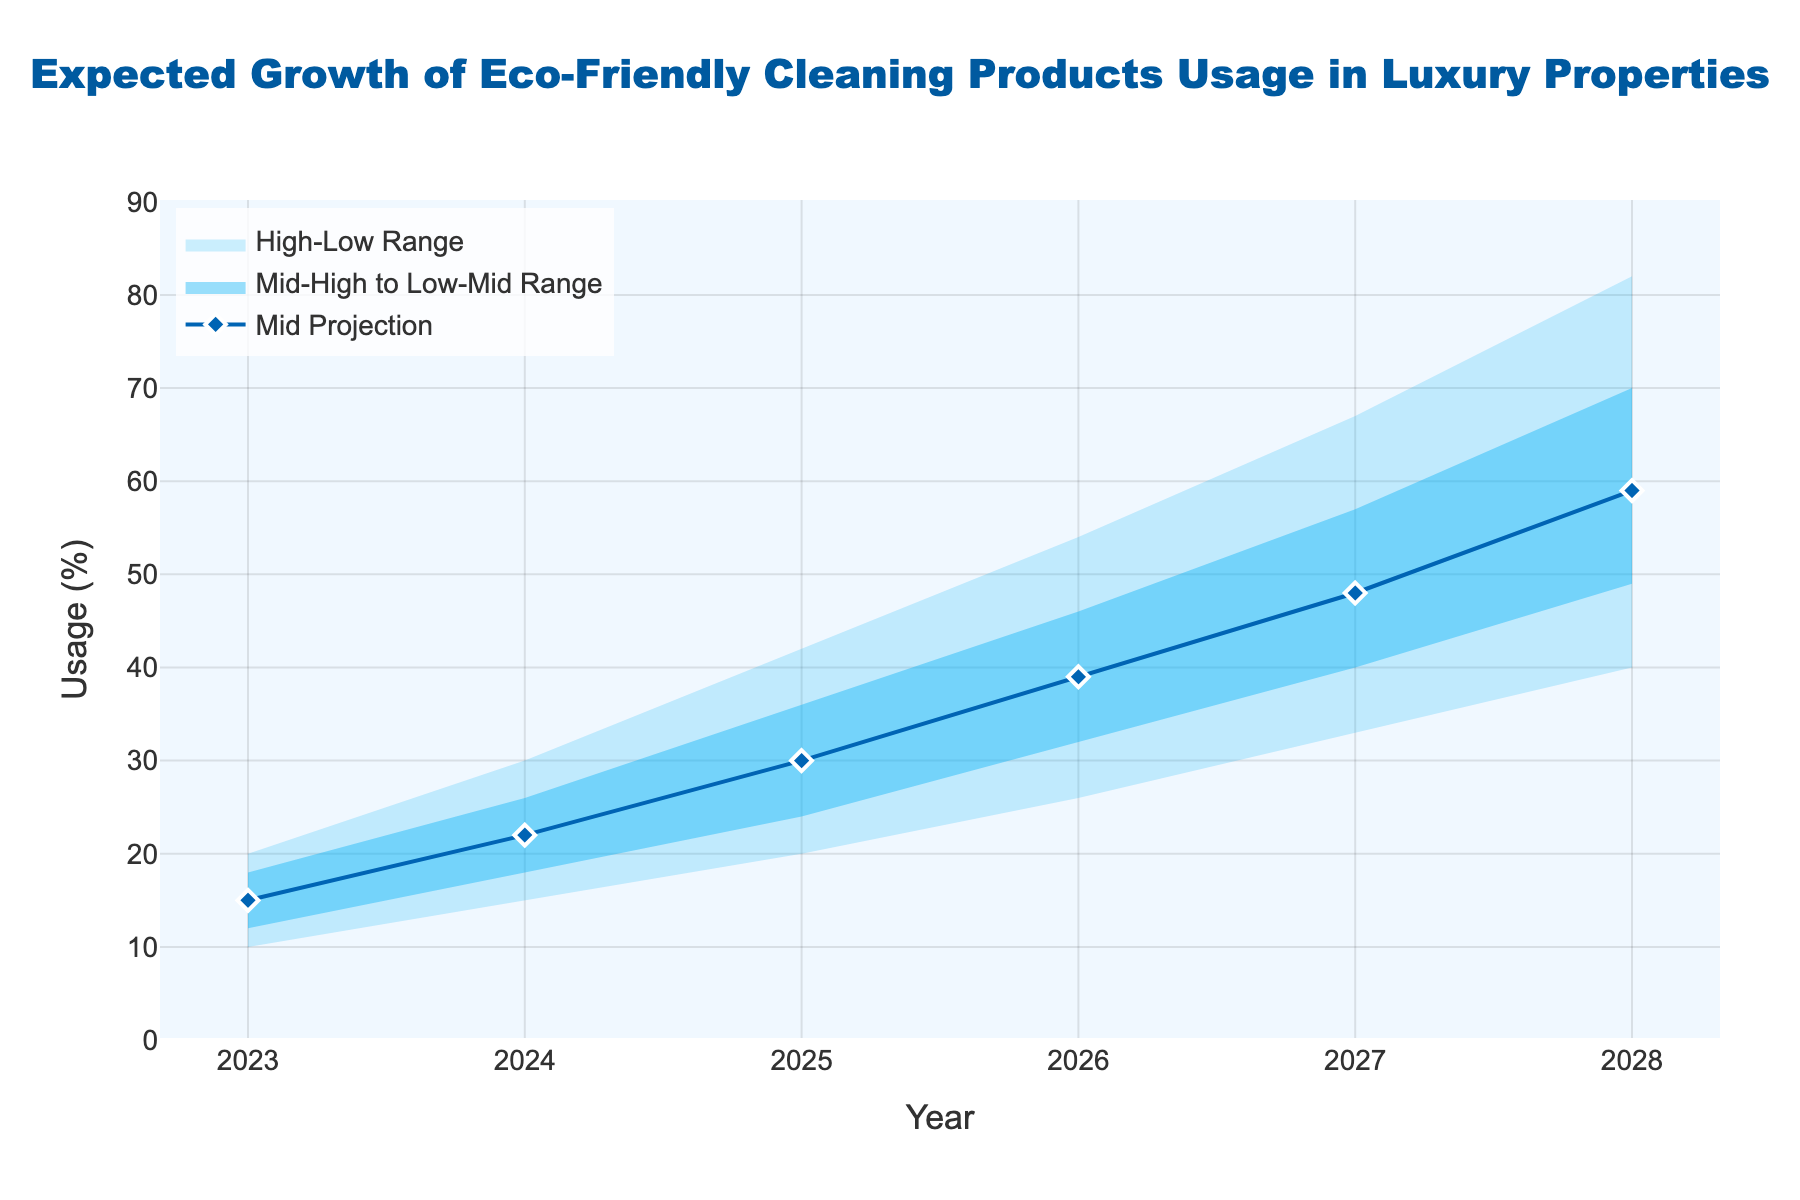What's the title of the fan chart? Look at the top center of the chart to find the title which clearly states the purpose of the graph.
Answer: Expected Growth of Eco-Friendly Cleaning Products Usage in Luxury Properties What percentage range does the chart predict for eco-friendly cleaning product usage in 2024? Locate the year 2024 on the x-axis and refer to the corresponding range on the y-axis. The predicted range spans from the Low (15%) to the High (30%) values.
Answer: 15% - 30% By how much does the mid projection increase from 2023 to 2025? Identify the mid values for the years 2023 and 2025 from the chart. Subtract the mid value in 2023 (15) from the mid value in 2025 (30).
Answer: 15% Which year shows the broadest range in predicted usage percentages? Compare the differences between the High and Low values for each year. The broadest range is seen by identifying the largest difference, which is from 2028 with a range of 42 (82 - 40).
Answer: 2028 What is the predicted mid value for 2027 and how does it compare to the mid value for 2023? Locate the mid values for 2023 and 2027 from the chart. The mid value for 2023 is 15, and for 2027, it is 48. Then determine the difference (48 - 15).
Answer: 33% higher What's the average yearly increase in the mid projection from 2024 to 2028? Identify the mid values for each year from 2024 to 2028 (22, 30, 39, 48, 59). Calculate the total increase ((59-22)/4).
Answer: 9.25% Between which years does the mid projection first exceed 30%? Identify the mid values for each year and determine when the mid value first surpasses 30%. It first exceeds 30 between 2024 and 2025.
Answer: Between 2024 and 2025 In 2026, what’s the difference between the low and mid-high projections? Identify the low (26) and mid-high (46) values for the year 2026, then subtract the low value from the mid-high value (46 - 26).
Answer: 20% By how much does the high value increase from 2023 to 2027? Identify the high values for the years 2023 and 2027, then subtract the high value in 2023 (20) from the high value in 2027 (67).
Answer: 47% What is the trend in the usage of eco-friendly cleaning products from 2023 to 2028 based on the mid projections? Observe the mid projections over the years (15 in 2023, 22 in 2024, 30 in 2025, 39 in 2026, 48 in 2027, and 59 in 2028) to identify a steady increasing trend.
Answer: Increasing trend 